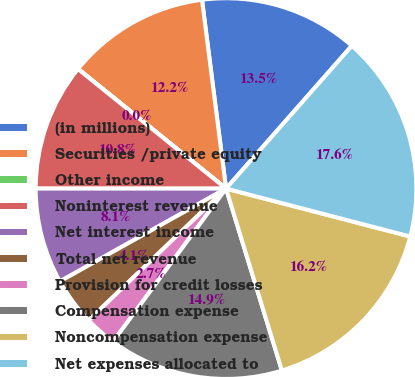<chart> <loc_0><loc_0><loc_500><loc_500><pie_chart><fcel>(in millions)<fcel>Securities /private equity<fcel>Other income<fcel>Noninterest revenue<fcel>Net interest income<fcel>Total net revenue<fcel>Provision for credit losses<fcel>Compensation expense<fcel>Noncompensation expense<fcel>Net expenses allocated to<nl><fcel>13.51%<fcel>12.16%<fcel>0.01%<fcel>10.81%<fcel>8.11%<fcel>4.06%<fcel>2.71%<fcel>14.86%<fcel>16.21%<fcel>17.56%<nl></chart> 